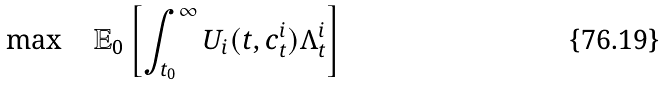<formula> <loc_0><loc_0><loc_500><loc_500>\max \quad \mathbb { E } _ { 0 } \left [ \int _ { t _ { 0 } } ^ { \infty } U _ { i } ( t , c _ { t } ^ { i } ) \Lambda ^ { i } _ { t } \right ]</formula> 